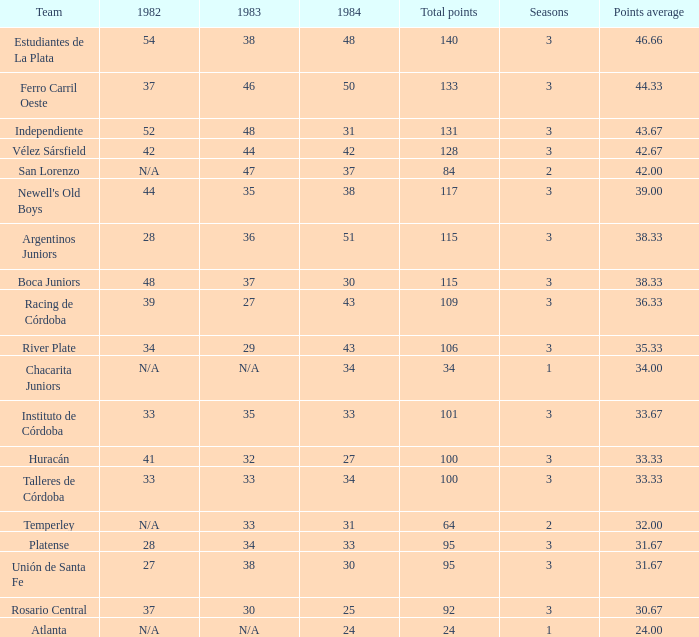For the team with a total under 24, what is their season count? None. 